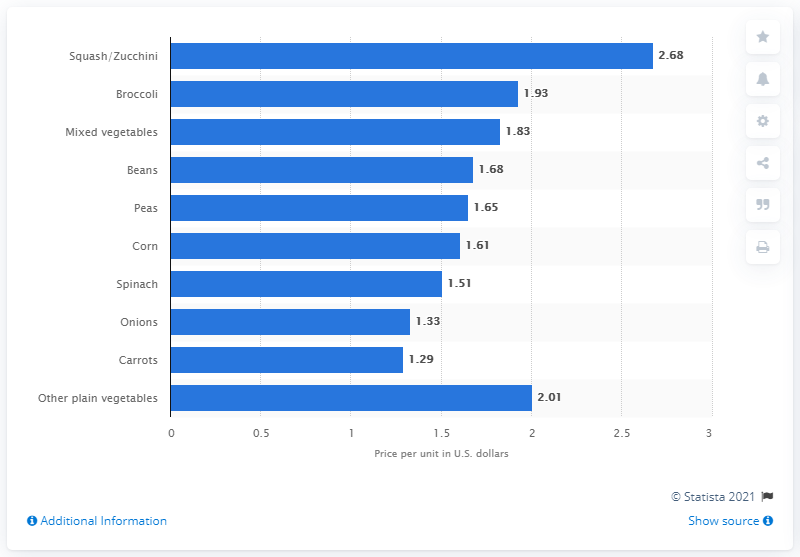Identify some key points in this picture. The price per unit of frozen broccoli in the United States for the 52 weeks ended November 7, 2018, was 1.93. 